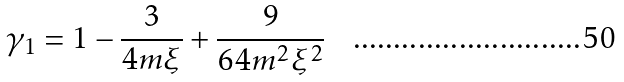<formula> <loc_0><loc_0><loc_500><loc_500>\gamma _ { 1 } = 1 - \frac { 3 } { 4 m \xi } + \frac { 9 } { 6 4 m ^ { 2 } \xi ^ { 2 } }</formula> 